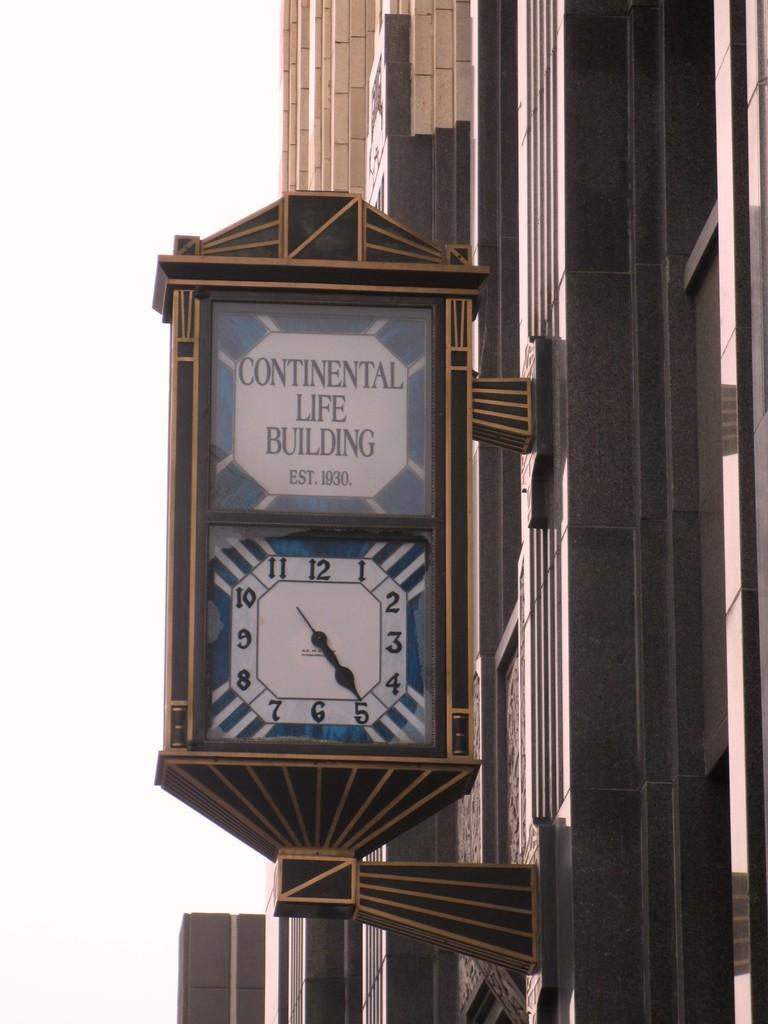Provide a one-sentence caption for the provided image. The Continental Life Building is 89 years old. 